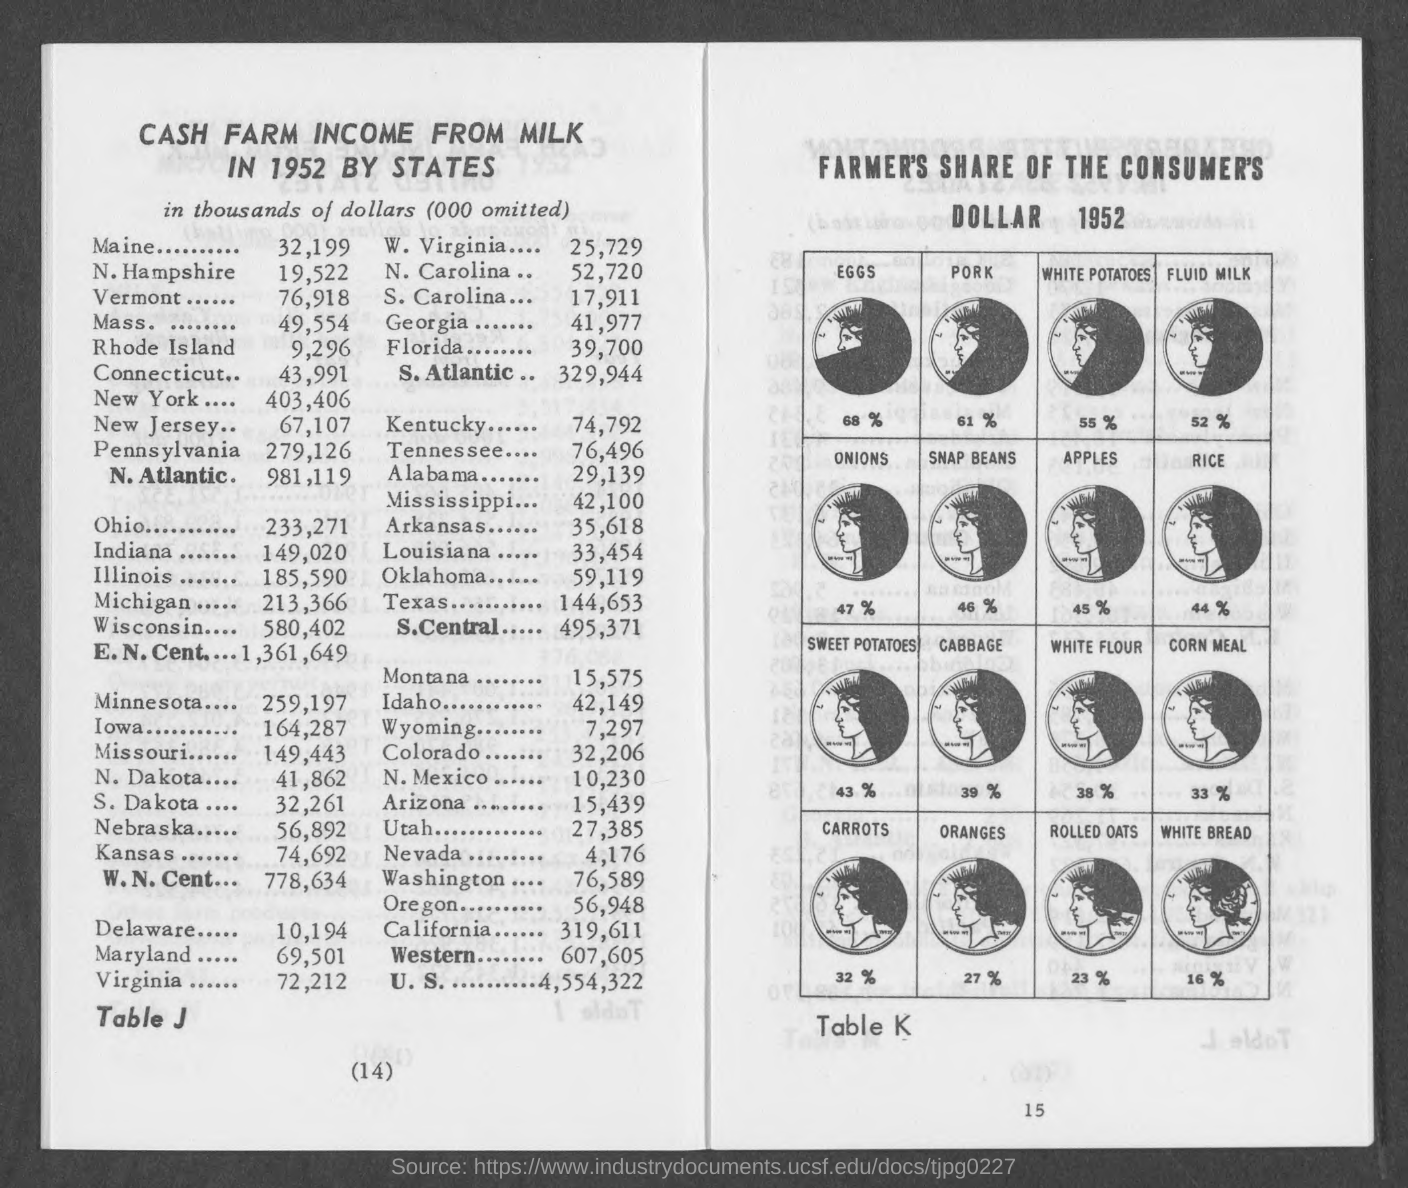Identify some key points in this picture. In 1952, the Cash Farm income from milk in Illinois was $185,590. In 1952, the cash farm income from milk in Massachusetts was approximately 49,554. The cash farm income from milk in New Hampshire in 1952 was 19,522. In 1952, the Cash Farm income from milk in New Jersey was 67,107. The cash farm income from milk in New York in 1952 was 403,406. 